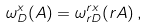<formula> <loc_0><loc_0><loc_500><loc_500>\omega ^ { x } _ { D } ( A ) = \omega ^ { r x } _ { r D } ( r A ) \, ,</formula> 